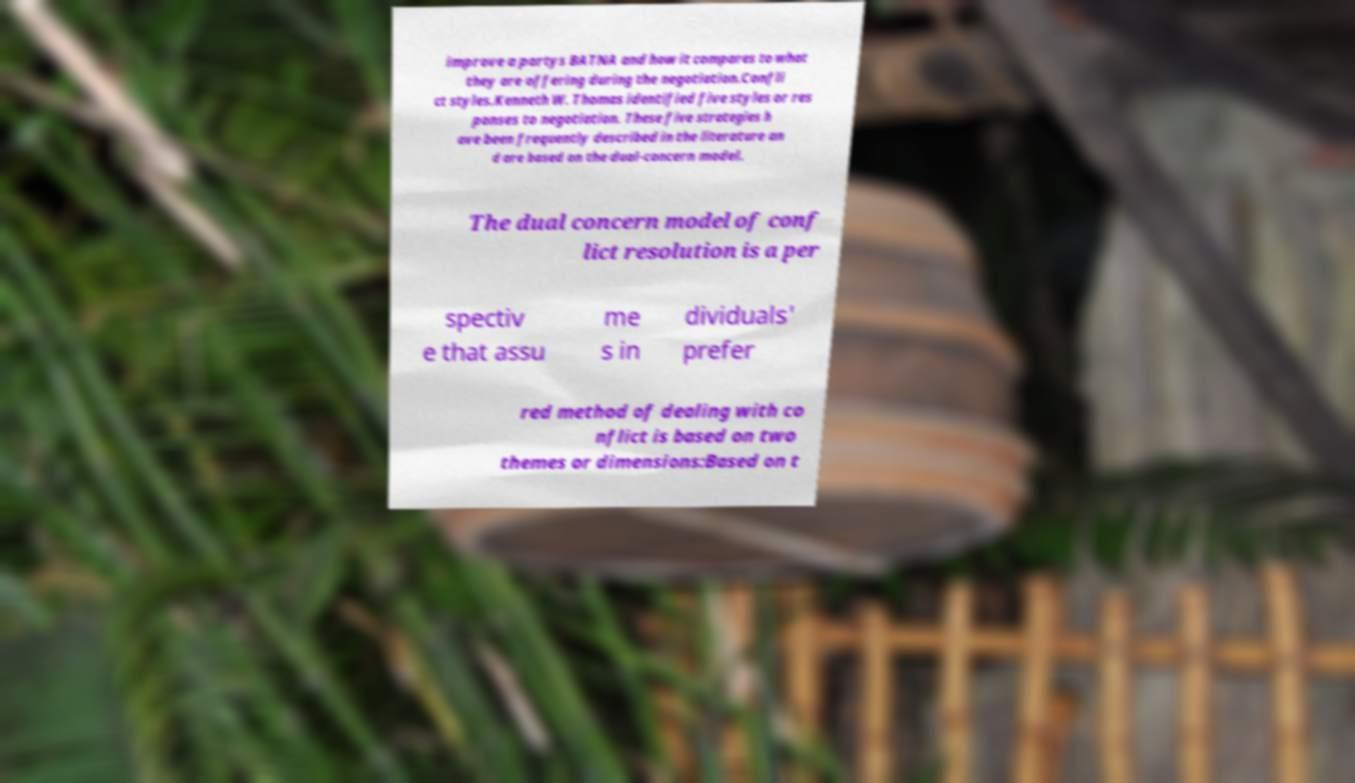Can you read and provide the text displayed in the image?This photo seems to have some interesting text. Can you extract and type it out for me? improve a partys BATNA and how it compares to what they are offering during the negotiation.Confli ct styles.Kenneth W. Thomas identified five styles or res ponses to negotiation. These five strategies h ave been frequently described in the literature an d are based on the dual-concern model. The dual concern model of conf lict resolution is a per spectiv e that assu me s in dividuals' prefer red method of dealing with co nflict is based on two themes or dimensions:Based on t 